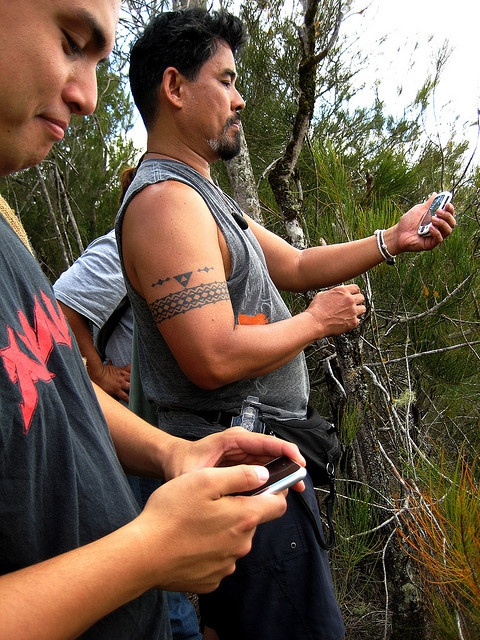Describe the objects in this image and their specific colors. I can see people in brown, black, and tan tones, people in brown, black, maroon, and gray tones, people in brown, gray, maroon, lavender, and black tones, cell phone in brown, black, white, maroon, and gray tones, and cell phone in brown, white, gray, and darkgray tones in this image. 